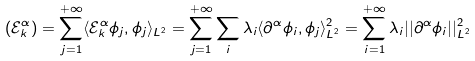<formula> <loc_0><loc_0><loc_500><loc_500>( \mathcal { E } _ { k } ^ { \alpha } ) = \sum _ { j = 1 } ^ { + \infty } \langle \mathcal { E } _ { k } ^ { \alpha } \phi _ { j } , \phi _ { j } \rangle _ { L ^ { 2 } } = \sum _ { j = 1 } ^ { + \infty } \sum _ { i } \lambda _ { i } \langle \partial ^ { \alpha } \phi _ { i } , \phi _ { j } \rangle _ { L ^ { 2 } } ^ { 2 } = \sum _ { i = 1 } ^ { + \infty } \lambda _ { i } | | \partial ^ { \alpha } \phi _ { i } | | _ { L ^ { 2 } } ^ { 2 }</formula> 